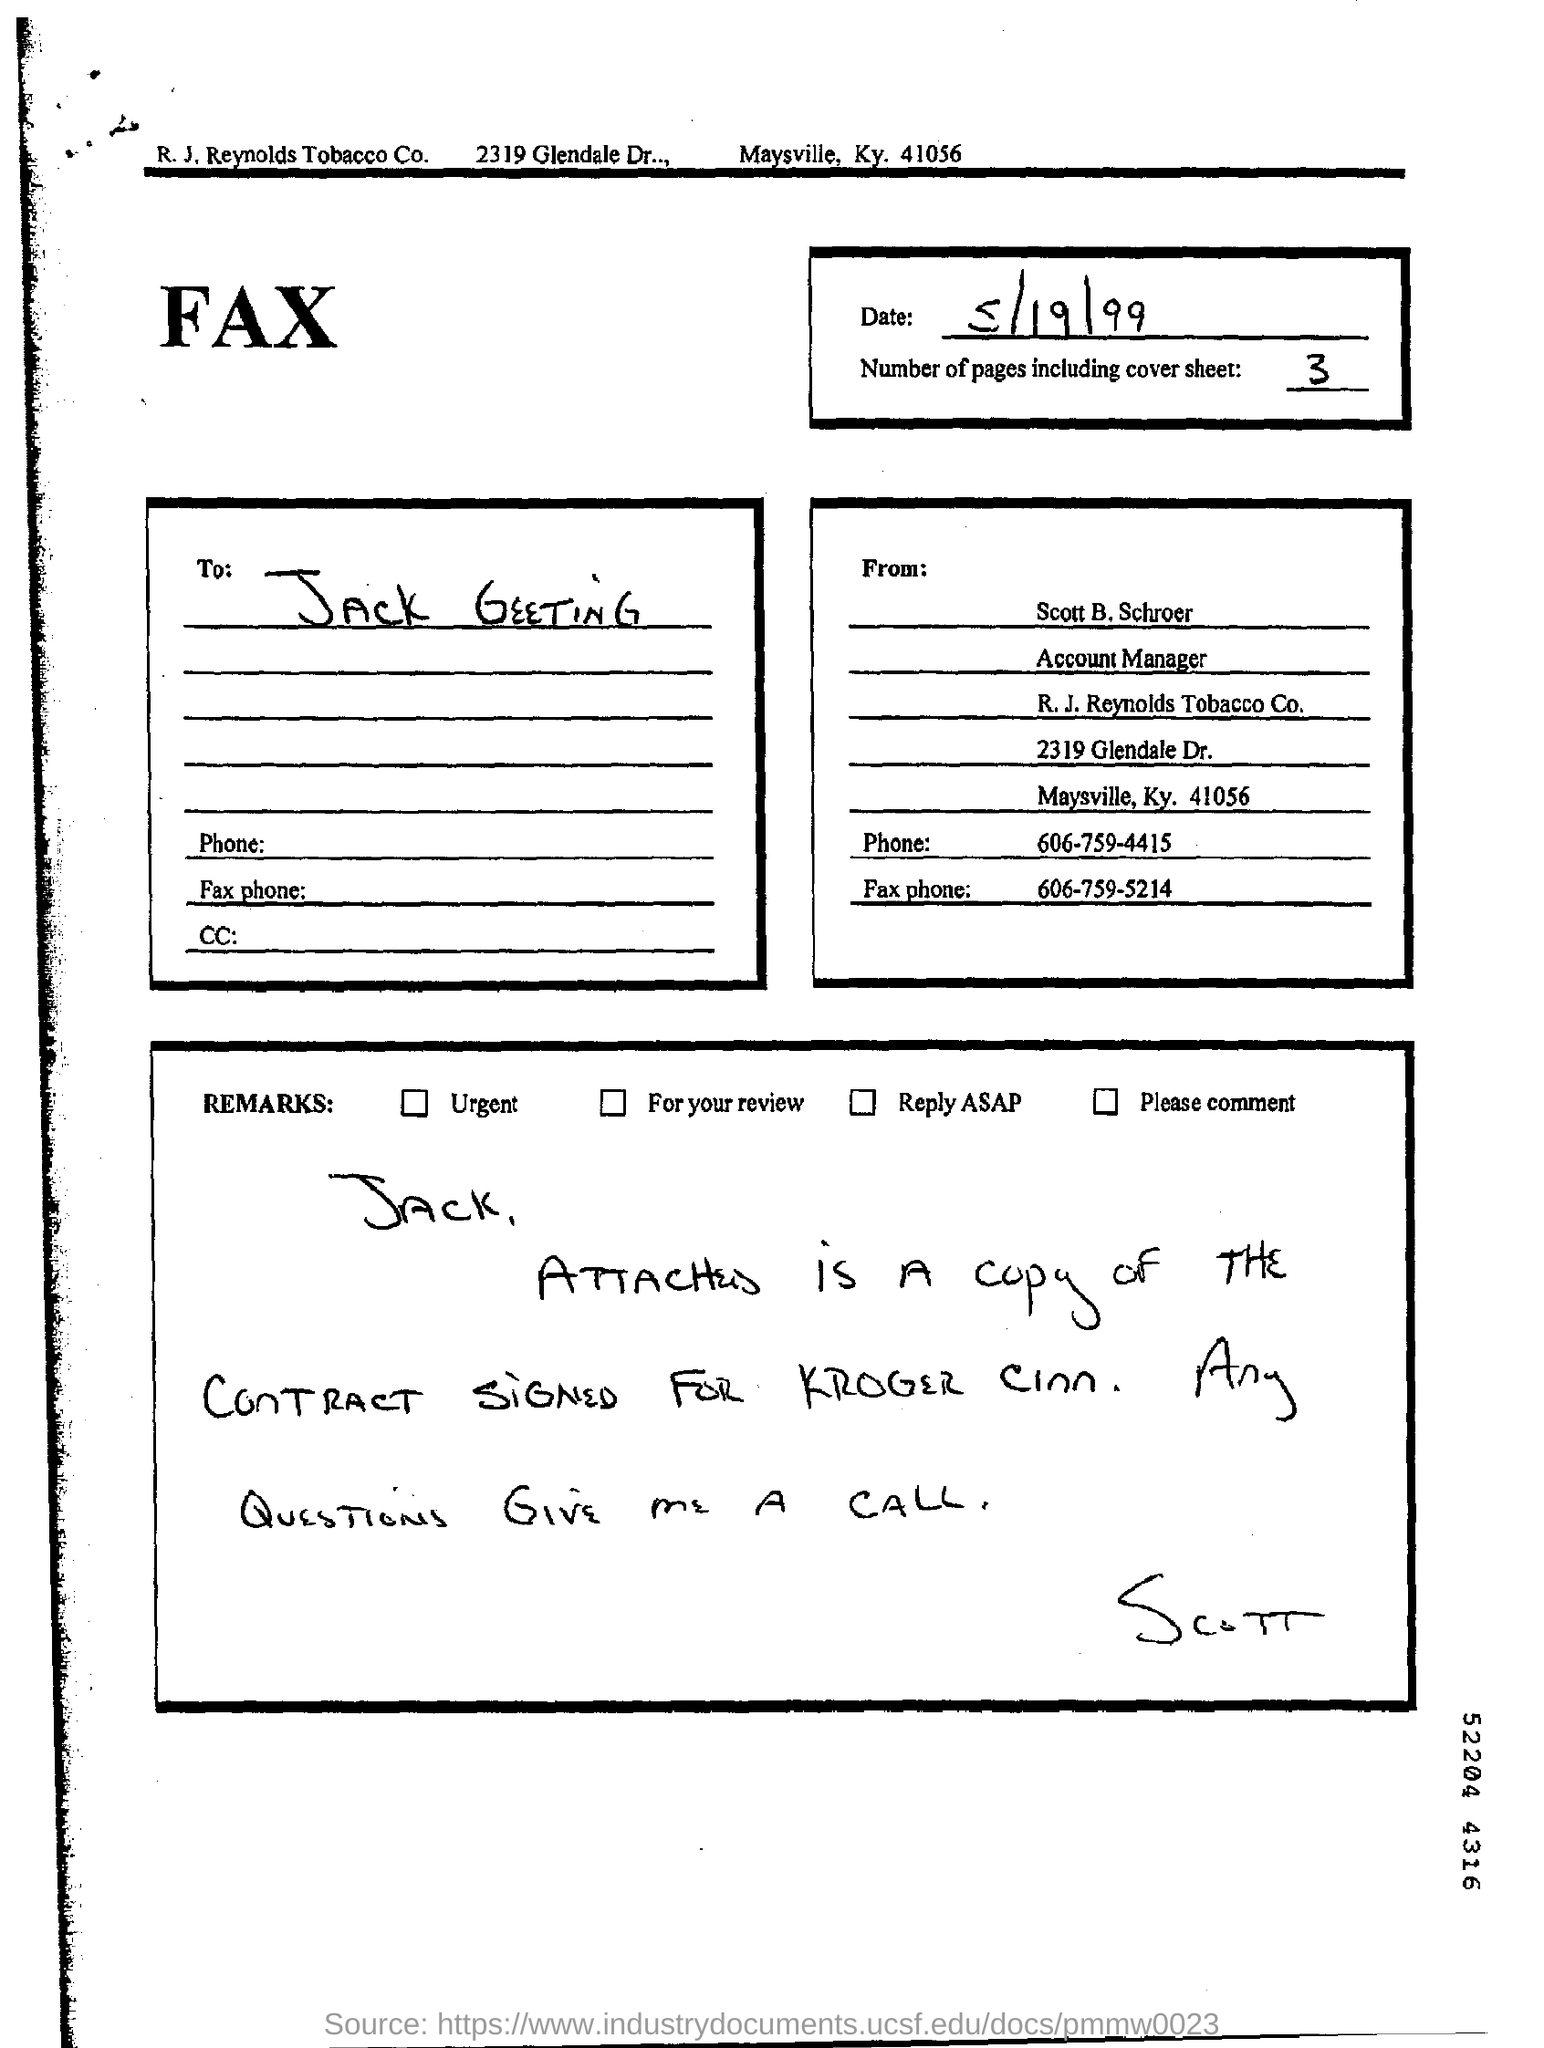Outline some significant characteristics in this image. The phone number provided is 606-759-5214. Scott B. Schroer's designation is Account Manager. The date mentioned in the FAX sheet is May 19th, 1999. The sender of the FAX is Scott B. Schroer. The phone number of Scott B. Schroer is 606-759-4415. 